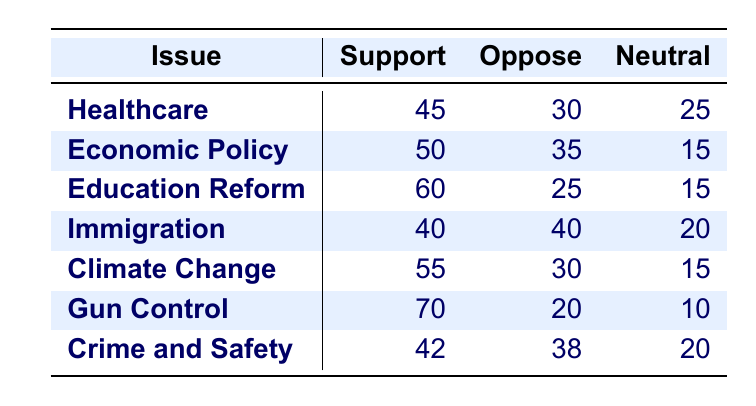What issue has the highest support according to the polling responses? By looking at the "Support" column in the table, we can compare the values for each issue. The values are: Healthcare (45), Economic Policy (50), Education Reform (60), Immigration (40), Climate Change (55), Gun Control (70), and Crime and Safety (42). The highest support value is 70 for Gun Control.
Answer: Gun Control What percentage of people supported Economic Policy? The table shows that 50 people supported Economic Policy. To calculate the percentage, we need the total number of responses for Economic Policy. The total responses are Support (50) + Oppose (35) + Neutral (15) = 100. Thus, the percentage of support is (50/100) * 100 = 50%.
Answer: 50% Is the number of people opposing Immigration equal to the number of people opposing Climate Change? From the table, the number of people opposing Immigration is 40 and the number of people opposing Climate Change is also 30. Since 40 is not equal to 30, the answer is no.
Answer: No What is the combined support for Healthcare and Climate Change? We sum the support values for both issues: Healthcare (45) + Climate Change (55) = 100. Thus, the combined support for these two issues is 100.
Answer: 100 Which issue has the least neutral responses? We compare the "Neutral" responses for each issue: Healthcare (25), Economic Policy (15), Education Reform (15), Immigration (20), Climate Change (15), Gun Control (10), and Crime and Safety (20). The least neutral responses are 10 for Gun Control.
Answer: Gun Control What is the difference in support between Education Reform and Gun Control? First, we find the support values: Education Reform (60) and Gun Control (70). The difference is calculated as 70 - 60 = 10. Therefore, the difference in support is 10.
Answer: 10 Are more people in favor of Climate Change than in favor of Immigration? The number of supporters for Climate Change is 55 and for Immigration is 40. Since 55 is greater than 40, the answer is yes.
Answer: Yes What is the average support across all issues? We sum up the support values: 45 + 50 + 60 + 40 + 55 + 70 + 42 = 412. With 7 issues, the average support is 412 / 7 ≈ 58.86 (rounded to 58.9).
Answer: 58.9 